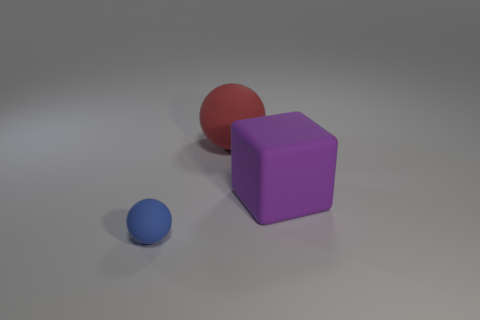Are there any other things that have the same size as the blue object?
Offer a very short reply. No. Does the matte cube have the same color as the big rubber sphere?
Provide a short and direct response. No. What number of rubber objects have the same size as the blue matte sphere?
Provide a short and direct response. 0. Are there more big purple matte cubes behind the large red thing than small matte objects that are behind the big rubber cube?
Ensure brevity in your answer.  No. What color is the matte sphere behind the matte object that is in front of the purple rubber thing?
Keep it short and to the point. Red. Is the blue sphere made of the same material as the big ball?
Provide a short and direct response. Yes. Is there a yellow matte object that has the same shape as the big purple thing?
Provide a short and direct response. No. There is a rubber ball that is right of the blue thing; does it have the same color as the rubber cube?
Ensure brevity in your answer.  No. There is a ball that is in front of the red rubber sphere; is it the same size as the ball that is behind the tiny ball?
Offer a very short reply. No. There is a blue object that is the same material as the large cube; what size is it?
Make the answer very short. Small. 